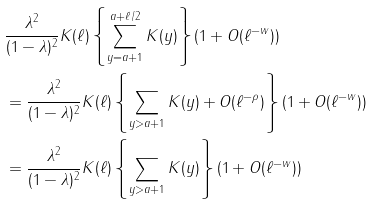<formula> <loc_0><loc_0><loc_500><loc_500>& \cfrac { \lambda ^ { 2 } } { ( 1 - \lambda ) ^ { 2 } } \, K ( \ell ) \left \{ \sum _ { y = a + 1 } ^ { a + \ell / 2 } K ( y ) \right \} ( 1 + O ( \ell ^ { - w } ) ) \\ & = \cfrac { \lambda ^ { 2 } } { ( 1 - \lambda ) ^ { 2 } } \, K ( \ell ) \left \{ \sum _ { y > a + 1 } K ( y ) + O ( \ell ^ { - \rho } ) \right \} ( 1 + O ( \ell ^ { - w } ) ) \\ & = \cfrac { \lambda ^ { 2 } } { ( 1 - \lambda ) ^ { 2 } } \, K ( \ell ) \left \{ \sum _ { y > a + 1 } K ( y ) \right \} ( 1 + O ( \ell ^ { - w } ) )</formula> 